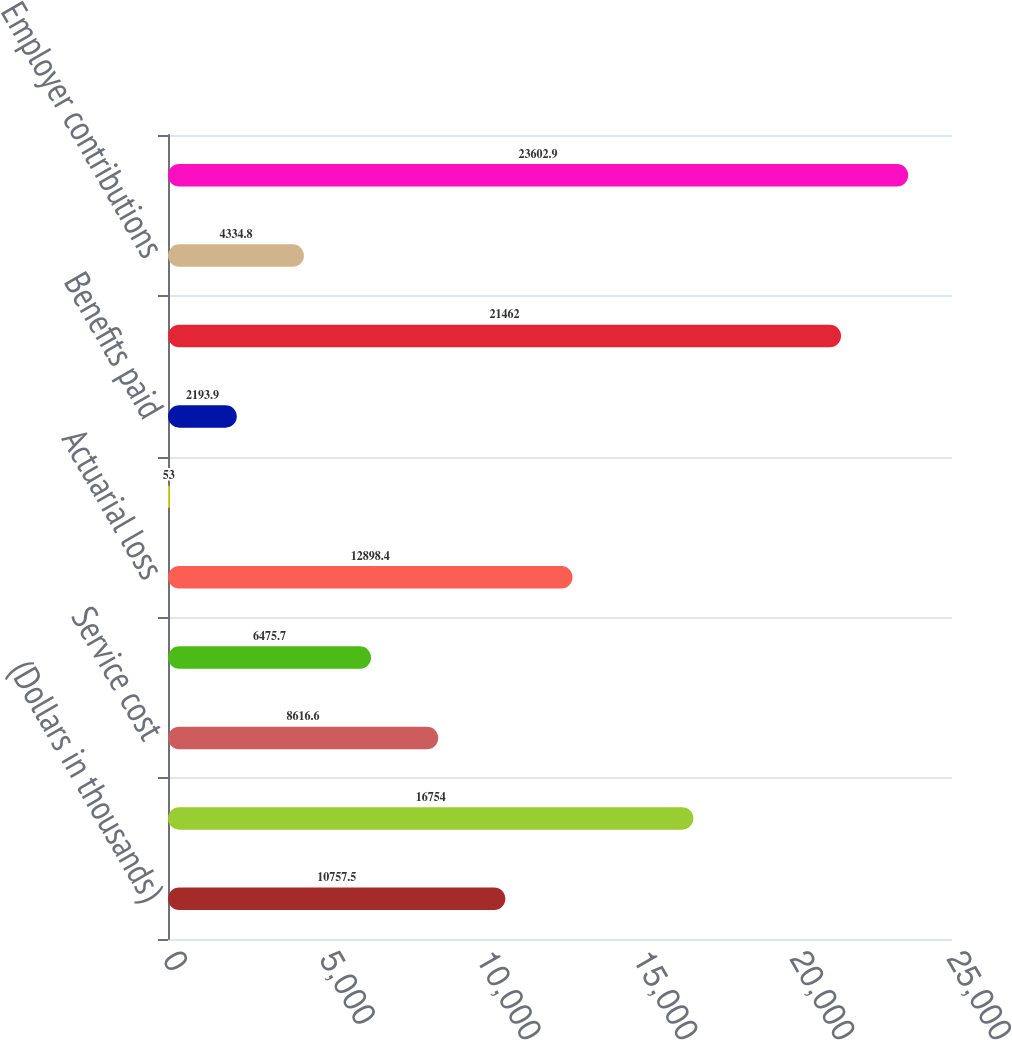Convert chart. <chart><loc_0><loc_0><loc_500><loc_500><bar_chart><fcel>(Dollars in thousands)<fcel>Benefit obligation at<fcel>Service cost<fcel>Interest cost<fcel>Actuarial loss<fcel>Excise tax cost<fcel>Benefits paid<fcel>Benefit obligation at end of<fcel>Employer contributions<fcel>Funded status at end of year<nl><fcel>10757.5<fcel>16754<fcel>8616.6<fcel>6475.7<fcel>12898.4<fcel>53<fcel>2193.9<fcel>21462<fcel>4334.8<fcel>23602.9<nl></chart> 